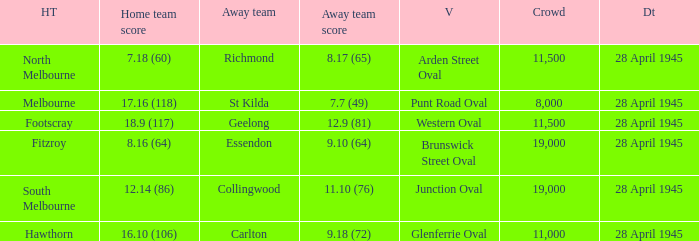Give me the full table as a dictionary. {'header': ['HT', 'Home team score', 'Away team', 'Away team score', 'V', 'Crowd', 'Dt'], 'rows': [['North Melbourne', '7.18 (60)', 'Richmond', '8.17 (65)', 'Arden Street Oval', '11,500', '28 April 1945'], ['Melbourne', '17.16 (118)', 'St Kilda', '7.7 (49)', 'Punt Road Oval', '8,000', '28 April 1945'], ['Footscray', '18.9 (117)', 'Geelong', '12.9 (81)', 'Western Oval', '11,500', '28 April 1945'], ['Fitzroy', '8.16 (64)', 'Essendon', '9.10 (64)', 'Brunswick Street Oval', '19,000', '28 April 1945'], ['South Melbourne', '12.14 (86)', 'Collingwood', '11.10 (76)', 'Junction Oval', '19,000', '28 April 1945'], ['Hawthorn', '16.10 (106)', 'Carlton', '9.18 (72)', 'Glenferrie Oval', '11,000', '28 April 1945']]} Which away team has a Home team score of 12.14 (86)? 11.10 (76). 